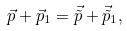<formula> <loc_0><loc_0><loc_500><loc_500>\vec { p } + \vec { p } _ { 1 } = \vec { \tilde { p } } + \vec { \tilde { p } } _ { 1 } ,</formula> 